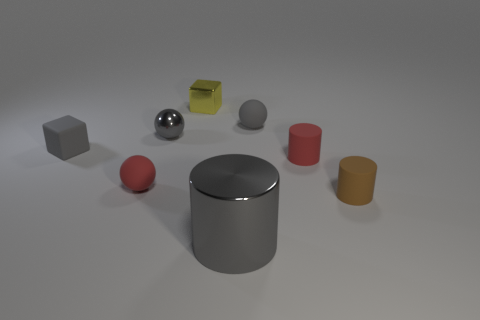Subtract all tiny metallic spheres. How many spheres are left? 2 Subtract all yellow blocks. How many blocks are left? 1 Subtract 2 cubes. How many cubes are left? 0 Subtract all cylinders. How many objects are left? 5 Add 1 small gray matte spheres. How many objects exist? 9 Subtract all red spheres. How many red cylinders are left? 1 Add 7 tiny green rubber blocks. How many tiny green rubber blocks exist? 7 Subtract 0 yellow cylinders. How many objects are left? 8 Subtract all purple spheres. Subtract all purple cylinders. How many spheres are left? 3 Subtract all small metallic objects. Subtract all green shiny blocks. How many objects are left? 6 